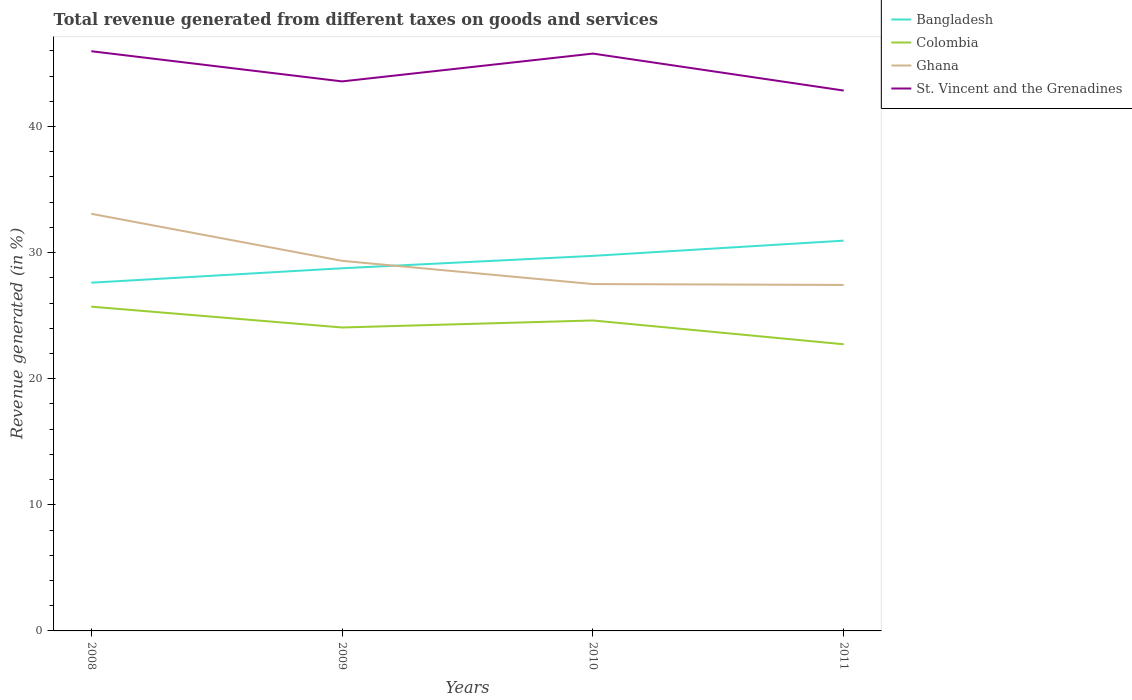How many different coloured lines are there?
Your answer should be compact. 4. Across all years, what is the maximum total revenue generated in Ghana?
Your response must be concise. 27.44. In which year was the total revenue generated in Ghana maximum?
Your answer should be very brief. 2011. What is the total total revenue generated in Colombia in the graph?
Offer a terse response. 1.09. What is the difference between the highest and the second highest total revenue generated in Ghana?
Provide a succinct answer. 5.64. What is the difference between the highest and the lowest total revenue generated in Ghana?
Your answer should be compact. 2. Is the total revenue generated in Ghana strictly greater than the total revenue generated in Bangladesh over the years?
Ensure brevity in your answer.  No. What is the difference between two consecutive major ticks on the Y-axis?
Offer a very short reply. 10. How many legend labels are there?
Provide a succinct answer. 4. What is the title of the graph?
Ensure brevity in your answer.  Total revenue generated from different taxes on goods and services. Does "Kosovo" appear as one of the legend labels in the graph?
Offer a terse response. No. What is the label or title of the Y-axis?
Provide a short and direct response. Revenue generated (in %). What is the Revenue generated (in %) of Bangladesh in 2008?
Your answer should be compact. 27.61. What is the Revenue generated (in %) in Colombia in 2008?
Make the answer very short. 25.71. What is the Revenue generated (in %) in Ghana in 2008?
Offer a terse response. 33.08. What is the Revenue generated (in %) in St. Vincent and the Grenadines in 2008?
Offer a very short reply. 45.97. What is the Revenue generated (in %) of Bangladesh in 2009?
Make the answer very short. 28.76. What is the Revenue generated (in %) in Colombia in 2009?
Your answer should be very brief. 24.06. What is the Revenue generated (in %) of Ghana in 2009?
Your answer should be compact. 29.35. What is the Revenue generated (in %) of St. Vincent and the Grenadines in 2009?
Provide a succinct answer. 43.58. What is the Revenue generated (in %) in Bangladesh in 2010?
Keep it short and to the point. 29.74. What is the Revenue generated (in %) in Colombia in 2010?
Ensure brevity in your answer.  24.62. What is the Revenue generated (in %) of Ghana in 2010?
Keep it short and to the point. 27.51. What is the Revenue generated (in %) of St. Vincent and the Grenadines in 2010?
Provide a succinct answer. 45.78. What is the Revenue generated (in %) in Bangladesh in 2011?
Make the answer very short. 30.95. What is the Revenue generated (in %) of Colombia in 2011?
Provide a short and direct response. 22.73. What is the Revenue generated (in %) in Ghana in 2011?
Provide a succinct answer. 27.44. What is the Revenue generated (in %) in St. Vincent and the Grenadines in 2011?
Keep it short and to the point. 42.85. Across all years, what is the maximum Revenue generated (in %) of Bangladesh?
Provide a short and direct response. 30.95. Across all years, what is the maximum Revenue generated (in %) in Colombia?
Give a very brief answer. 25.71. Across all years, what is the maximum Revenue generated (in %) in Ghana?
Offer a terse response. 33.08. Across all years, what is the maximum Revenue generated (in %) of St. Vincent and the Grenadines?
Your answer should be very brief. 45.97. Across all years, what is the minimum Revenue generated (in %) in Bangladesh?
Your answer should be compact. 27.61. Across all years, what is the minimum Revenue generated (in %) of Colombia?
Your answer should be very brief. 22.73. Across all years, what is the minimum Revenue generated (in %) of Ghana?
Your response must be concise. 27.44. Across all years, what is the minimum Revenue generated (in %) in St. Vincent and the Grenadines?
Keep it short and to the point. 42.85. What is the total Revenue generated (in %) in Bangladesh in the graph?
Your response must be concise. 117.06. What is the total Revenue generated (in %) of Colombia in the graph?
Make the answer very short. 97.13. What is the total Revenue generated (in %) of Ghana in the graph?
Your answer should be very brief. 117.37. What is the total Revenue generated (in %) of St. Vincent and the Grenadines in the graph?
Provide a succinct answer. 178.18. What is the difference between the Revenue generated (in %) of Bangladesh in 2008 and that in 2009?
Offer a terse response. -1.14. What is the difference between the Revenue generated (in %) in Colombia in 2008 and that in 2009?
Keep it short and to the point. 1.65. What is the difference between the Revenue generated (in %) of Ghana in 2008 and that in 2009?
Provide a short and direct response. 3.73. What is the difference between the Revenue generated (in %) in St. Vincent and the Grenadines in 2008 and that in 2009?
Ensure brevity in your answer.  2.39. What is the difference between the Revenue generated (in %) in Bangladesh in 2008 and that in 2010?
Provide a short and direct response. -2.13. What is the difference between the Revenue generated (in %) of Colombia in 2008 and that in 2010?
Offer a very short reply. 1.09. What is the difference between the Revenue generated (in %) in Ghana in 2008 and that in 2010?
Your answer should be very brief. 5.57. What is the difference between the Revenue generated (in %) in St. Vincent and the Grenadines in 2008 and that in 2010?
Your answer should be very brief. 0.19. What is the difference between the Revenue generated (in %) in Bangladesh in 2008 and that in 2011?
Your response must be concise. -3.33. What is the difference between the Revenue generated (in %) of Colombia in 2008 and that in 2011?
Ensure brevity in your answer.  2.98. What is the difference between the Revenue generated (in %) of Ghana in 2008 and that in 2011?
Keep it short and to the point. 5.64. What is the difference between the Revenue generated (in %) of St. Vincent and the Grenadines in 2008 and that in 2011?
Your answer should be compact. 3.12. What is the difference between the Revenue generated (in %) in Bangladesh in 2009 and that in 2010?
Your answer should be compact. -0.98. What is the difference between the Revenue generated (in %) in Colombia in 2009 and that in 2010?
Give a very brief answer. -0.56. What is the difference between the Revenue generated (in %) of Ghana in 2009 and that in 2010?
Your response must be concise. 1.84. What is the difference between the Revenue generated (in %) in St. Vincent and the Grenadines in 2009 and that in 2010?
Keep it short and to the point. -2.21. What is the difference between the Revenue generated (in %) in Bangladesh in 2009 and that in 2011?
Offer a very short reply. -2.19. What is the difference between the Revenue generated (in %) in Colombia in 2009 and that in 2011?
Your response must be concise. 1.33. What is the difference between the Revenue generated (in %) of Ghana in 2009 and that in 2011?
Keep it short and to the point. 1.91. What is the difference between the Revenue generated (in %) in St. Vincent and the Grenadines in 2009 and that in 2011?
Give a very brief answer. 0.73. What is the difference between the Revenue generated (in %) of Bangladesh in 2010 and that in 2011?
Offer a very short reply. -1.21. What is the difference between the Revenue generated (in %) of Colombia in 2010 and that in 2011?
Your answer should be compact. 1.89. What is the difference between the Revenue generated (in %) in Ghana in 2010 and that in 2011?
Provide a short and direct response. 0.07. What is the difference between the Revenue generated (in %) in St. Vincent and the Grenadines in 2010 and that in 2011?
Offer a terse response. 2.93. What is the difference between the Revenue generated (in %) in Bangladesh in 2008 and the Revenue generated (in %) in Colombia in 2009?
Your response must be concise. 3.55. What is the difference between the Revenue generated (in %) of Bangladesh in 2008 and the Revenue generated (in %) of Ghana in 2009?
Offer a very short reply. -1.73. What is the difference between the Revenue generated (in %) of Bangladesh in 2008 and the Revenue generated (in %) of St. Vincent and the Grenadines in 2009?
Give a very brief answer. -15.96. What is the difference between the Revenue generated (in %) in Colombia in 2008 and the Revenue generated (in %) in Ghana in 2009?
Your answer should be compact. -3.63. What is the difference between the Revenue generated (in %) in Colombia in 2008 and the Revenue generated (in %) in St. Vincent and the Grenadines in 2009?
Offer a very short reply. -17.86. What is the difference between the Revenue generated (in %) in Ghana in 2008 and the Revenue generated (in %) in St. Vincent and the Grenadines in 2009?
Offer a terse response. -10.5. What is the difference between the Revenue generated (in %) in Bangladesh in 2008 and the Revenue generated (in %) in Colombia in 2010?
Provide a succinct answer. 2.99. What is the difference between the Revenue generated (in %) in Bangladesh in 2008 and the Revenue generated (in %) in Ghana in 2010?
Your answer should be very brief. 0.11. What is the difference between the Revenue generated (in %) of Bangladesh in 2008 and the Revenue generated (in %) of St. Vincent and the Grenadines in 2010?
Offer a very short reply. -18.17. What is the difference between the Revenue generated (in %) in Colombia in 2008 and the Revenue generated (in %) in Ghana in 2010?
Provide a short and direct response. -1.79. What is the difference between the Revenue generated (in %) of Colombia in 2008 and the Revenue generated (in %) of St. Vincent and the Grenadines in 2010?
Provide a succinct answer. -20.07. What is the difference between the Revenue generated (in %) of Ghana in 2008 and the Revenue generated (in %) of St. Vincent and the Grenadines in 2010?
Your answer should be compact. -12.71. What is the difference between the Revenue generated (in %) of Bangladesh in 2008 and the Revenue generated (in %) of Colombia in 2011?
Your answer should be very brief. 4.88. What is the difference between the Revenue generated (in %) of Bangladesh in 2008 and the Revenue generated (in %) of Ghana in 2011?
Your answer should be very brief. 0.18. What is the difference between the Revenue generated (in %) of Bangladesh in 2008 and the Revenue generated (in %) of St. Vincent and the Grenadines in 2011?
Your answer should be very brief. -15.24. What is the difference between the Revenue generated (in %) of Colombia in 2008 and the Revenue generated (in %) of Ghana in 2011?
Give a very brief answer. -1.72. What is the difference between the Revenue generated (in %) of Colombia in 2008 and the Revenue generated (in %) of St. Vincent and the Grenadines in 2011?
Offer a terse response. -17.14. What is the difference between the Revenue generated (in %) of Ghana in 2008 and the Revenue generated (in %) of St. Vincent and the Grenadines in 2011?
Make the answer very short. -9.77. What is the difference between the Revenue generated (in %) in Bangladesh in 2009 and the Revenue generated (in %) in Colombia in 2010?
Keep it short and to the point. 4.14. What is the difference between the Revenue generated (in %) of Bangladesh in 2009 and the Revenue generated (in %) of Ghana in 2010?
Provide a short and direct response. 1.25. What is the difference between the Revenue generated (in %) of Bangladesh in 2009 and the Revenue generated (in %) of St. Vincent and the Grenadines in 2010?
Keep it short and to the point. -17.02. What is the difference between the Revenue generated (in %) in Colombia in 2009 and the Revenue generated (in %) in Ghana in 2010?
Provide a succinct answer. -3.44. What is the difference between the Revenue generated (in %) in Colombia in 2009 and the Revenue generated (in %) in St. Vincent and the Grenadines in 2010?
Your response must be concise. -21.72. What is the difference between the Revenue generated (in %) of Ghana in 2009 and the Revenue generated (in %) of St. Vincent and the Grenadines in 2010?
Make the answer very short. -16.44. What is the difference between the Revenue generated (in %) of Bangladesh in 2009 and the Revenue generated (in %) of Colombia in 2011?
Make the answer very short. 6.03. What is the difference between the Revenue generated (in %) in Bangladesh in 2009 and the Revenue generated (in %) in Ghana in 2011?
Ensure brevity in your answer.  1.32. What is the difference between the Revenue generated (in %) in Bangladesh in 2009 and the Revenue generated (in %) in St. Vincent and the Grenadines in 2011?
Provide a short and direct response. -14.09. What is the difference between the Revenue generated (in %) of Colombia in 2009 and the Revenue generated (in %) of Ghana in 2011?
Offer a very short reply. -3.37. What is the difference between the Revenue generated (in %) in Colombia in 2009 and the Revenue generated (in %) in St. Vincent and the Grenadines in 2011?
Offer a terse response. -18.79. What is the difference between the Revenue generated (in %) in Ghana in 2009 and the Revenue generated (in %) in St. Vincent and the Grenadines in 2011?
Your response must be concise. -13.5. What is the difference between the Revenue generated (in %) in Bangladesh in 2010 and the Revenue generated (in %) in Colombia in 2011?
Give a very brief answer. 7.01. What is the difference between the Revenue generated (in %) in Bangladesh in 2010 and the Revenue generated (in %) in Ghana in 2011?
Offer a very short reply. 2.3. What is the difference between the Revenue generated (in %) of Bangladesh in 2010 and the Revenue generated (in %) of St. Vincent and the Grenadines in 2011?
Make the answer very short. -13.11. What is the difference between the Revenue generated (in %) in Colombia in 2010 and the Revenue generated (in %) in Ghana in 2011?
Offer a very short reply. -2.82. What is the difference between the Revenue generated (in %) in Colombia in 2010 and the Revenue generated (in %) in St. Vincent and the Grenadines in 2011?
Offer a very short reply. -18.23. What is the difference between the Revenue generated (in %) of Ghana in 2010 and the Revenue generated (in %) of St. Vincent and the Grenadines in 2011?
Make the answer very short. -15.35. What is the average Revenue generated (in %) of Bangladesh per year?
Offer a very short reply. 29.27. What is the average Revenue generated (in %) of Colombia per year?
Offer a very short reply. 24.28. What is the average Revenue generated (in %) of Ghana per year?
Your answer should be very brief. 29.34. What is the average Revenue generated (in %) of St. Vincent and the Grenadines per year?
Make the answer very short. 44.55. In the year 2008, what is the difference between the Revenue generated (in %) of Bangladesh and Revenue generated (in %) of Colombia?
Ensure brevity in your answer.  1.9. In the year 2008, what is the difference between the Revenue generated (in %) of Bangladesh and Revenue generated (in %) of Ghana?
Provide a short and direct response. -5.46. In the year 2008, what is the difference between the Revenue generated (in %) of Bangladesh and Revenue generated (in %) of St. Vincent and the Grenadines?
Make the answer very short. -18.36. In the year 2008, what is the difference between the Revenue generated (in %) in Colombia and Revenue generated (in %) in Ghana?
Your answer should be very brief. -7.36. In the year 2008, what is the difference between the Revenue generated (in %) of Colombia and Revenue generated (in %) of St. Vincent and the Grenadines?
Keep it short and to the point. -20.26. In the year 2008, what is the difference between the Revenue generated (in %) of Ghana and Revenue generated (in %) of St. Vincent and the Grenadines?
Make the answer very short. -12.89. In the year 2009, what is the difference between the Revenue generated (in %) in Bangladesh and Revenue generated (in %) in Colombia?
Give a very brief answer. 4.7. In the year 2009, what is the difference between the Revenue generated (in %) of Bangladesh and Revenue generated (in %) of Ghana?
Provide a succinct answer. -0.59. In the year 2009, what is the difference between the Revenue generated (in %) of Bangladesh and Revenue generated (in %) of St. Vincent and the Grenadines?
Keep it short and to the point. -14.82. In the year 2009, what is the difference between the Revenue generated (in %) in Colombia and Revenue generated (in %) in Ghana?
Provide a short and direct response. -5.28. In the year 2009, what is the difference between the Revenue generated (in %) of Colombia and Revenue generated (in %) of St. Vincent and the Grenadines?
Make the answer very short. -19.51. In the year 2009, what is the difference between the Revenue generated (in %) in Ghana and Revenue generated (in %) in St. Vincent and the Grenadines?
Ensure brevity in your answer.  -14.23. In the year 2010, what is the difference between the Revenue generated (in %) in Bangladesh and Revenue generated (in %) in Colombia?
Offer a terse response. 5.12. In the year 2010, what is the difference between the Revenue generated (in %) of Bangladesh and Revenue generated (in %) of Ghana?
Give a very brief answer. 2.23. In the year 2010, what is the difference between the Revenue generated (in %) of Bangladesh and Revenue generated (in %) of St. Vincent and the Grenadines?
Give a very brief answer. -16.04. In the year 2010, what is the difference between the Revenue generated (in %) in Colombia and Revenue generated (in %) in Ghana?
Give a very brief answer. -2.89. In the year 2010, what is the difference between the Revenue generated (in %) in Colombia and Revenue generated (in %) in St. Vincent and the Grenadines?
Your answer should be very brief. -21.16. In the year 2010, what is the difference between the Revenue generated (in %) in Ghana and Revenue generated (in %) in St. Vincent and the Grenadines?
Keep it short and to the point. -18.28. In the year 2011, what is the difference between the Revenue generated (in %) in Bangladesh and Revenue generated (in %) in Colombia?
Offer a terse response. 8.22. In the year 2011, what is the difference between the Revenue generated (in %) in Bangladesh and Revenue generated (in %) in Ghana?
Your answer should be compact. 3.51. In the year 2011, what is the difference between the Revenue generated (in %) of Bangladesh and Revenue generated (in %) of St. Vincent and the Grenadines?
Ensure brevity in your answer.  -11.9. In the year 2011, what is the difference between the Revenue generated (in %) of Colombia and Revenue generated (in %) of Ghana?
Keep it short and to the point. -4.71. In the year 2011, what is the difference between the Revenue generated (in %) of Colombia and Revenue generated (in %) of St. Vincent and the Grenadines?
Give a very brief answer. -20.12. In the year 2011, what is the difference between the Revenue generated (in %) of Ghana and Revenue generated (in %) of St. Vincent and the Grenadines?
Keep it short and to the point. -15.41. What is the ratio of the Revenue generated (in %) of Bangladesh in 2008 to that in 2009?
Give a very brief answer. 0.96. What is the ratio of the Revenue generated (in %) of Colombia in 2008 to that in 2009?
Make the answer very short. 1.07. What is the ratio of the Revenue generated (in %) in Ghana in 2008 to that in 2009?
Keep it short and to the point. 1.13. What is the ratio of the Revenue generated (in %) of St. Vincent and the Grenadines in 2008 to that in 2009?
Your response must be concise. 1.05. What is the ratio of the Revenue generated (in %) of Bangladesh in 2008 to that in 2010?
Ensure brevity in your answer.  0.93. What is the ratio of the Revenue generated (in %) in Colombia in 2008 to that in 2010?
Ensure brevity in your answer.  1.04. What is the ratio of the Revenue generated (in %) of Ghana in 2008 to that in 2010?
Make the answer very short. 1.2. What is the ratio of the Revenue generated (in %) of Bangladesh in 2008 to that in 2011?
Your answer should be compact. 0.89. What is the ratio of the Revenue generated (in %) in Colombia in 2008 to that in 2011?
Your answer should be compact. 1.13. What is the ratio of the Revenue generated (in %) of Ghana in 2008 to that in 2011?
Ensure brevity in your answer.  1.21. What is the ratio of the Revenue generated (in %) in St. Vincent and the Grenadines in 2008 to that in 2011?
Your answer should be compact. 1.07. What is the ratio of the Revenue generated (in %) of Colombia in 2009 to that in 2010?
Provide a succinct answer. 0.98. What is the ratio of the Revenue generated (in %) of Ghana in 2009 to that in 2010?
Offer a very short reply. 1.07. What is the ratio of the Revenue generated (in %) in St. Vincent and the Grenadines in 2009 to that in 2010?
Offer a terse response. 0.95. What is the ratio of the Revenue generated (in %) of Bangladesh in 2009 to that in 2011?
Offer a very short reply. 0.93. What is the ratio of the Revenue generated (in %) in Colombia in 2009 to that in 2011?
Give a very brief answer. 1.06. What is the ratio of the Revenue generated (in %) of Ghana in 2009 to that in 2011?
Make the answer very short. 1.07. What is the ratio of the Revenue generated (in %) of St. Vincent and the Grenadines in 2009 to that in 2011?
Give a very brief answer. 1.02. What is the ratio of the Revenue generated (in %) of Colombia in 2010 to that in 2011?
Your response must be concise. 1.08. What is the ratio of the Revenue generated (in %) in St. Vincent and the Grenadines in 2010 to that in 2011?
Provide a short and direct response. 1.07. What is the difference between the highest and the second highest Revenue generated (in %) in Bangladesh?
Offer a very short reply. 1.21. What is the difference between the highest and the second highest Revenue generated (in %) in Colombia?
Your response must be concise. 1.09. What is the difference between the highest and the second highest Revenue generated (in %) of Ghana?
Ensure brevity in your answer.  3.73. What is the difference between the highest and the second highest Revenue generated (in %) of St. Vincent and the Grenadines?
Give a very brief answer. 0.19. What is the difference between the highest and the lowest Revenue generated (in %) of Bangladesh?
Provide a succinct answer. 3.33. What is the difference between the highest and the lowest Revenue generated (in %) of Colombia?
Keep it short and to the point. 2.98. What is the difference between the highest and the lowest Revenue generated (in %) in Ghana?
Keep it short and to the point. 5.64. What is the difference between the highest and the lowest Revenue generated (in %) of St. Vincent and the Grenadines?
Provide a succinct answer. 3.12. 